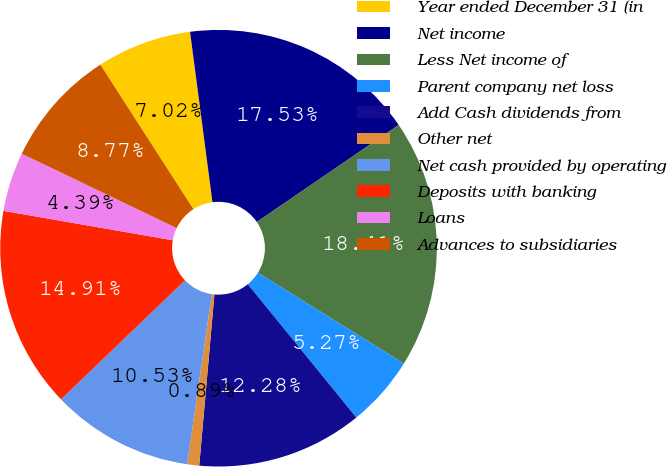Convert chart. <chart><loc_0><loc_0><loc_500><loc_500><pie_chart><fcel>Year ended December 31 (in<fcel>Net income<fcel>Less Net income of<fcel>Parent company net loss<fcel>Add Cash dividends from<fcel>Other net<fcel>Net cash provided by operating<fcel>Deposits with banking<fcel>Loans<fcel>Advances to subsidiaries<nl><fcel>7.02%<fcel>17.53%<fcel>18.41%<fcel>5.27%<fcel>12.28%<fcel>0.89%<fcel>10.53%<fcel>14.91%<fcel>4.39%<fcel>8.77%<nl></chart> 